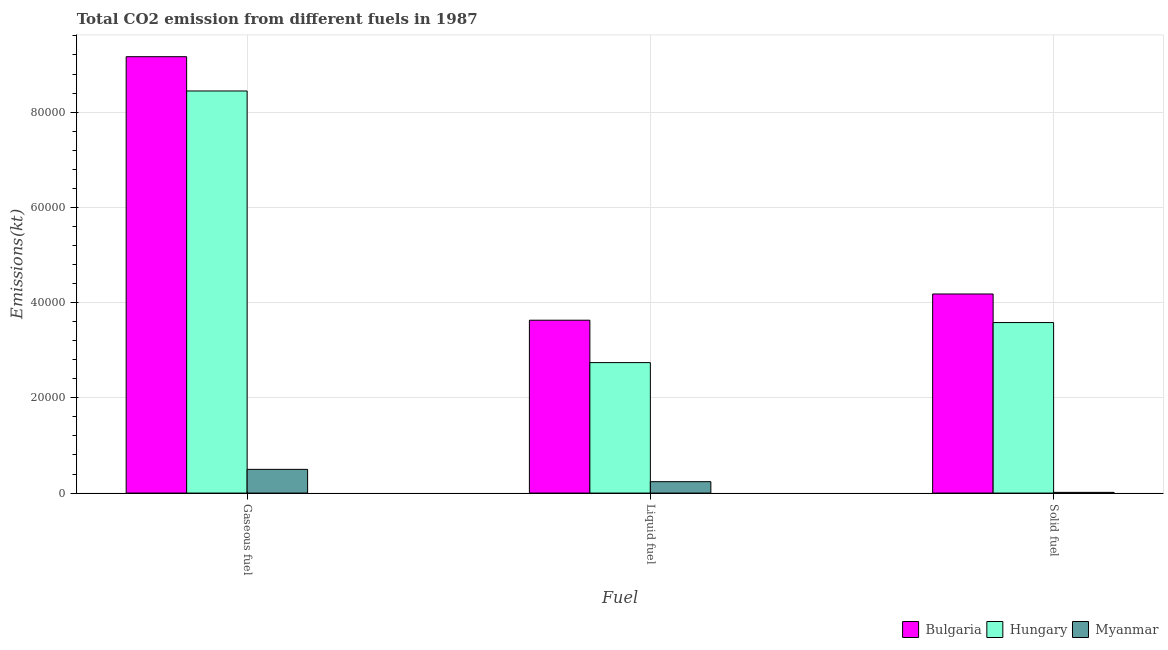How many different coloured bars are there?
Provide a short and direct response. 3. Are the number of bars on each tick of the X-axis equal?
Make the answer very short. Yes. How many bars are there on the 3rd tick from the left?
Give a very brief answer. 3. What is the label of the 2nd group of bars from the left?
Your answer should be compact. Liquid fuel. What is the amount of co2 emissions from gaseous fuel in Hungary?
Make the answer very short. 8.44e+04. Across all countries, what is the maximum amount of co2 emissions from solid fuel?
Your response must be concise. 4.18e+04. Across all countries, what is the minimum amount of co2 emissions from solid fuel?
Your answer should be compact. 146.68. In which country was the amount of co2 emissions from liquid fuel minimum?
Offer a terse response. Myanmar. What is the total amount of co2 emissions from gaseous fuel in the graph?
Your response must be concise. 1.81e+05. What is the difference between the amount of co2 emissions from solid fuel in Bulgaria and that in Hungary?
Provide a short and direct response. 5999.21. What is the difference between the amount of co2 emissions from liquid fuel in Myanmar and the amount of co2 emissions from solid fuel in Hungary?
Offer a very short reply. -3.34e+04. What is the average amount of co2 emissions from solid fuel per country?
Provide a succinct answer. 2.59e+04. What is the difference between the amount of co2 emissions from gaseous fuel and amount of co2 emissions from solid fuel in Bulgaria?
Your answer should be compact. 4.98e+04. In how many countries, is the amount of co2 emissions from liquid fuel greater than 8000 kt?
Offer a terse response. 2. What is the ratio of the amount of co2 emissions from liquid fuel in Hungary to that in Myanmar?
Provide a short and direct response. 11.46. Is the difference between the amount of co2 emissions from gaseous fuel in Bulgaria and Hungary greater than the difference between the amount of co2 emissions from solid fuel in Bulgaria and Hungary?
Give a very brief answer. Yes. What is the difference between the highest and the second highest amount of co2 emissions from solid fuel?
Your answer should be compact. 5999.21. What is the difference between the highest and the lowest amount of co2 emissions from solid fuel?
Ensure brevity in your answer.  4.17e+04. In how many countries, is the amount of co2 emissions from gaseous fuel greater than the average amount of co2 emissions from gaseous fuel taken over all countries?
Provide a succinct answer. 2. Is the sum of the amount of co2 emissions from solid fuel in Bulgaria and Myanmar greater than the maximum amount of co2 emissions from gaseous fuel across all countries?
Provide a short and direct response. No. What does the 2nd bar from the left in Gaseous fuel represents?
Your response must be concise. Hungary. What does the 2nd bar from the right in Solid fuel represents?
Keep it short and to the point. Hungary. Are all the bars in the graph horizontal?
Keep it short and to the point. No. Are the values on the major ticks of Y-axis written in scientific E-notation?
Make the answer very short. No. Does the graph contain any zero values?
Ensure brevity in your answer.  No. Does the graph contain grids?
Provide a succinct answer. Yes. Where does the legend appear in the graph?
Provide a succinct answer. Bottom right. How many legend labels are there?
Offer a very short reply. 3. What is the title of the graph?
Your response must be concise. Total CO2 emission from different fuels in 1987. Does "Dominican Republic" appear as one of the legend labels in the graph?
Your answer should be very brief. No. What is the label or title of the X-axis?
Your answer should be very brief. Fuel. What is the label or title of the Y-axis?
Keep it short and to the point. Emissions(kt). What is the Emissions(kt) in Bulgaria in Gaseous fuel?
Offer a very short reply. 9.16e+04. What is the Emissions(kt) of Hungary in Gaseous fuel?
Offer a terse response. 8.44e+04. What is the Emissions(kt) in Myanmar in Gaseous fuel?
Offer a terse response. 4976.12. What is the Emissions(kt) of Bulgaria in Liquid fuel?
Your answer should be compact. 3.63e+04. What is the Emissions(kt) of Hungary in Liquid fuel?
Ensure brevity in your answer.  2.74e+04. What is the Emissions(kt) of Myanmar in Liquid fuel?
Keep it short and to the point. 2390.88. What is the Emissions(kt) in Bulgaria in Solid fuel?
Make the answer very short. 4.18e+04. What is the Emissions(kt) in Hungary in Solid fuel?
Offer a terse response. 3.58e+04. What is the Emissions(kt) in Myanmar in Solid fuel?
Your answer should be compact. 146.68. Across all Fuel, what is the maximum Emissions(kt) in Bulgaria?
Provide a succinct answer. 9.16e+04. Across all Fuel, what is the maximum Emissions(kt) in Hungary?
Provide a succinct answer. 8.44e+04. Across all Fuel, what is the maximum Emissions(kt) in Myanmar?
Offer a terse response. 4976.12. Across all Fuel, what is the minimum Emissions(kt) in Bulgaria?
Give a very brief answer. 3.63e+04. Across all Fuel, what is the minimum Emissions(kt) in Hungary?
Your answer should be compact. 2.74e+04. Across all Fuel, what is the minimum Emissions(kt) of Myanmar?
Offer a terse response. 146.68. What is the total Emissions(kt) in Bulgaria in the graph?
Give a very brief answer. 1.70e+05. What is the total Emissions(kt) of Hungary in the graph?
Make the answer very short. 1.48e+05. What is the total Emissions(kt) in Myanmar in the graph?
Provide a short and direct response. 7513.68. What is the difference between the Emissions(kt) of Bulgaria in Gaseous fuel and that in Liquid fuel?
Offer a terse response. 5.53e+04. What is the difference between the Emissions(kt) of Hungary in Gaseous fuel and that in Liquid fuel?
Provide a succinct answer. 5.70e+04. What is the difference between the Emissions(kt) of Myanmar in Gaseous fuel and that in Liquid fuel?
Your answer should be very brief. 2585.24. What is the difference between the Emissions(kt) in Bulgaria in Gaseous fuel and that in Solid fuel?
Your response must be concise. 4.98e+04. What is the difference between the Emissions(kt) of Hungary in Gaseous fuel and that in Solid fuel?
Your response must be concise. 4.86e+04. What is the difference between the Emissions(kt) of Myanmar in Gaseous fuel and that in Solid fuel?
Your response must be concise. 4829.44. What is the difference between the Emissions(kt) in Bulgaria in Liquid fuel and that in Solid fuel?
Ensure brevity in your answer.  -5507.83. What is the difference between the Emissions(kt) of Hungary in Liquid fuel and that in Solid fuel?
Offer a very short reply. -8412.1. What is the difference between the Emissions(kt) in Myanmar in Liquid fuel and that in Solid fuel?
Provide a short and direct response. 2244.2. What is the difference between the Emissions(kt) of Bulgaria in Gaseous fuel and the Emissions(kt) of Hungary in Liquid fuel?
Offer a terse response. 6.42e+04. What is the difference between the Emissions(kt) in Bulgaria in Gaseous fuel and the Emissions(kt) in Myanmar in Liquid fuel?
Provide a succinct answer. 8.92e+04. What is the difference between the Emissions(kt) in Hungary in Gaseous fuel and the Emissions(kt) in Myanmar in Liquid fuel?
Provide a short and direct response. 8.20e+04. What is the difference between the Emissions(kt) in Bulgaria in Gaseous fuel and the Emissions(kt) in Hungary in Solid fuel?
Ensure brevity in your answer.  5.58e+04. What is the difference between the Emissions(kt) of Bulgaria in Gaseous fuel and the Emissions(kt) of Myanmar in Solid fuel?
Provide a short and direct response. 9.15e+04. What is the difference between the Emissions(kt) in Hungary in Gaseous fuel and the Emissions(kt) in Myanmar in Solid fuel?
Your answer should be compact. 8.43e+04. What is the difference between the Emissions(kt) of Bulgaria in Liquid fuel and the Emissions(kt) of Hungary in Solid fuel?
Your response must be concise. 491.38. What is the difference between the Emissions(kt) of Bulgaria in Liquid fuel and the Emissions(kt) of Myanmar in Solid fuel?
Give a very brief answer. 3.62e+04. What is the difference between the Emissions(kt) in Hungary in Liquid fuel and the Emissions(kt) in Myanmar in Solid fuel?
Ensure brevity in your answer.  2.72e+04. What is the average Emissions(kt) in Bulgaria per Fuel?
Give a very brief answer. 5.66e+04. What is the average Emissions(kt) in Hungary per Fuel?
Give a very brief answer. 4.92e+04. What is the average Emissions(kt) in Myanmar per Fuel?
Offer a terse response. 2504.56. What is the difference between the Emissions(kt) in Bulgaria and Emissions(kt) in Hungary in Gaseous fuel?
Ensure brevity in your answer.  7198.32. What is the difference between the Emissions(kt) of Bulgaria and Emissions(kt) of Myanmar in Gaseous fuel?
Keep it short and to the point. 8.67e+04. What is the difference between the Emissions(kt) in Hungary and Emissions(kt) in Myanmar in Gaseous fuel?
Offer a terse response. 7.95e+04. What is the difference between the Emissions(kt) of Bulgaria and Emissions(kt) of Hungary in Liquid fuel?
Offer a terse response. 8903.48. What is the difference between the Emissions(kt) in Bulgaria and Emissions(kt) in Myanmar in Liquid fuel?
Offer a very short reply. 3.39e+04. What is the difference between the Emissions(kt) of Hungary and Emissions(kt) of Myanmar in Liquid fuel?
Offer a very short reply. 2.50e+04. What is the difference between the Emissions(kt) in Bulgaria and Emissions(kt) in Hungary in Solid fuel?
Your answer should be very brief. 5999.21. What is the difference between the Emissions(kt) in Bulgaria and Emissions(kt) in Myanmar in Solid fuel?
Make the answer very short. 4.17e+04. What is the difference between the Emissions(kt) in Hungary and Emissions(kt) in Myanmar in Solid fuel?
Your answer should be compact. 3.57e+04. What is the ratio of the Emissions(kt) in Bulgaria in Gaseous fuel to that in Liquid fuel?
Provide a succinct answer. 2.52. What is the ratio of the Emissions(kt) in Hungary in Gaseous fuel to that in Liquid fuel?
Your answer should be compact. 3.08. What is the ratio of the Emissions(kt) of Myanmar in Gaseous fuel to that in Liquid fuel?
Provide a succinct answer. 2.08. What is the ratio of the Emissions(kt) of Bulgaria in Gaseous fuel to that in Solid fuel?
Offer a very short reply. 2.19. What is the ratio of the Emissions(kt) of Hungary in Gaseous fuel to that in Solid fuel?
Offer a very short reply. 2.36. What is the ratio of the Emissions(kt) of Myanmar in Gaseous fuel to that in Solid fuel?
Offer a very short reply. 33.92. What is the ratio of the Emissions(kt) in Bulgaria in Liquid fuel to that in Solid fuel?
Ensure brevity in your answer.  0.87. What is the ratio of the Emissions(kt) in Hungary in Liquid fuel to that in Solid fuel?
Provide a succinct answer. 0.77. What is the ratio of the Emissions(kt) in Myanmar in Liquid fuel to that in Solid fuel?
Your response must be concise. 16.3. What is the difference between the highest and the second highest Emissions(kt) in Bulgaria?
Offer a terse response. 4.98e+04. What is the difference between the highest and the second highest Emissions(kt) in Hungary?
Keep it short and to the point. 4.86e+04. What is the difference between the highest and the second highest Emissions(kt) of Myanmar?
Your response must be concise. 2585.24. What is the difference between the highest and the lowest Emissions(kt) of Bulgaria?
Ensure brevity in your answer.  5.53e+04. What is the difference between the highest and the lowest Emissions(kt) of Hungary?
Offer a very short reply. 5.70e+04. What is the difference between the highest and the lowest Emissions(kt) of Myanmar?
Offer a very short reply. 4829.44. 